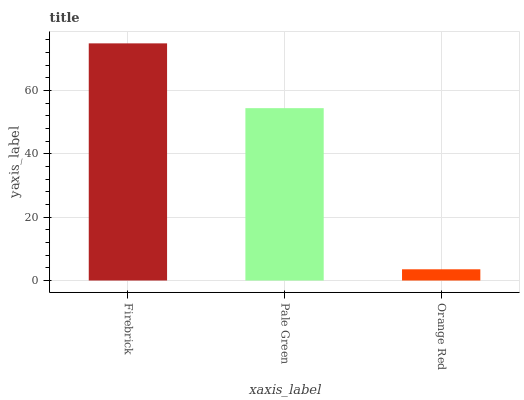Is Orange Red the minimum?
Answer yes or no. Yes. Is Firebrick the maximum?
Answer yes or no. Yes. Is Pale Green the minimum?
Answer yes or no. No. Is Pale Green the maximum?
Answer yes or no. No. Is Firebrick greater than Pale Green?
Answer yes or no. Yes. Is Pale Green less than Firebrick?
Answer yes or no. Yes. Is Pale Green greater than Firebrick?
Answer yes or no. No. Is Firebrick less than Pale Green?
Answer yes or no. No. Is Pale Green the high median?
Answer yes or no. Yes. Is Pale Green the low median?
Answer yes or no. Yes. Is Orange Red the high median?
Answer yes or no. No. Is Firebrick the low median?
Answer yes or no. No. 